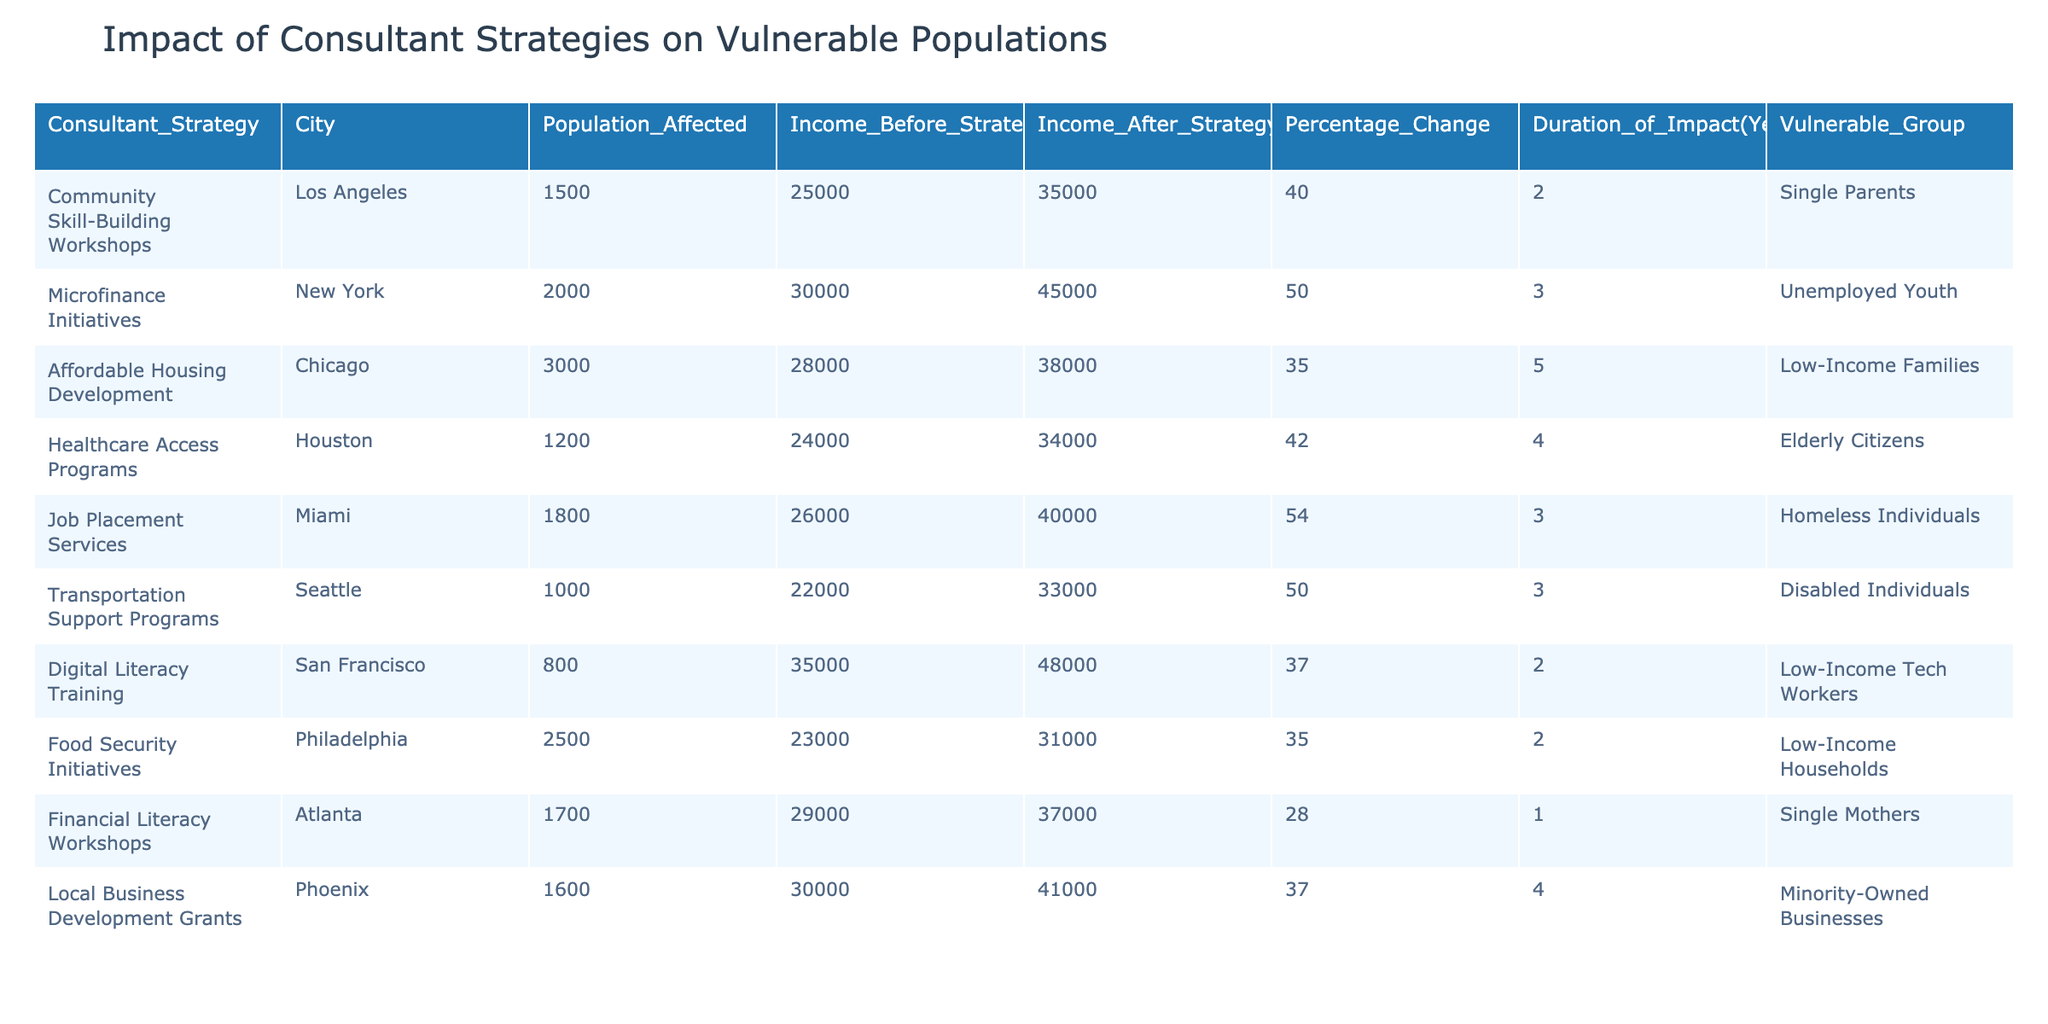What was the income increase for single parents in Los Angeles? The income before the strategy was 25,000, and after the strategy, it was 35,000. The increase is 35,000 - 25,000 = 10,000.
Answer: 10,000 Which consultant strategy had the highest percentage change in income? The strategy with the highest percentage change in income is "Job Placement Services" in Miami, which had a percentage change of 54%.
Answer: 54% How many low-income families were affected by the affordable housing development in Chicago? According to the table, the affordable housing development affected 3,000 low-income families.
Answer: 3,000 Is there a healthcare access program in Houston targeting elderly citizens? Yes, the table indicates that there is a healthcare access program in Houston targeting elderly citizens.
Answer: Yes What is the average income increase across all strategies listed? First, we calculate the income increases for each strategy: 10,000, 15,000, 18,000, 10,000, 14,000, 11,000, 13,000, 8,000, 8,000, 11,000. The sum is 10,000 + 15,000 + 18,000 + 10,000 + 14,000 + 11,000 + 13,000 + 8,000 + 8,000 + 11,000 = 118,000. There are 10 strategies, so the average increase is 118,000 / 10 = 11,800.
Answer: 11,800 How long did the impact of microfinance initiatives last? The table states that the microfinance initiatives lasted for a duration of 3 years.
Answer: 3 years Which city had the least population affected by a consultant strategy? "Digital Literacy Training" in San Francisco had the least population affected, with 800 individuals.
Answer: 800 What is the difference in income levels before and after the transportation support programs? The income before the strategy was 22,000, and after it was 33,000. The difference is 33,000 - 22,000 = 11,000.
Answer: 11,000 Did the job placement services in Miami improve income by more than 50%? Yes, the income increased from 26,000 to 40,000, which is a percentage change of 54%, exceeding 50%.
Answer: Yes What is the total population affected by all strategies combined? We sum the populations affected by each strategy: 1500 + 2000 + 3000 + 1200 + 1800 + 1000 + 800 + 2500 + 1700 + 1600 = 20,100.
Answer: 20,100 Which strategy had the lowest after-strategy income and what was that income? The "Food Security Initiatives" strategy had the lowest after-strategy income of 31,000.
Answer: 31,000 